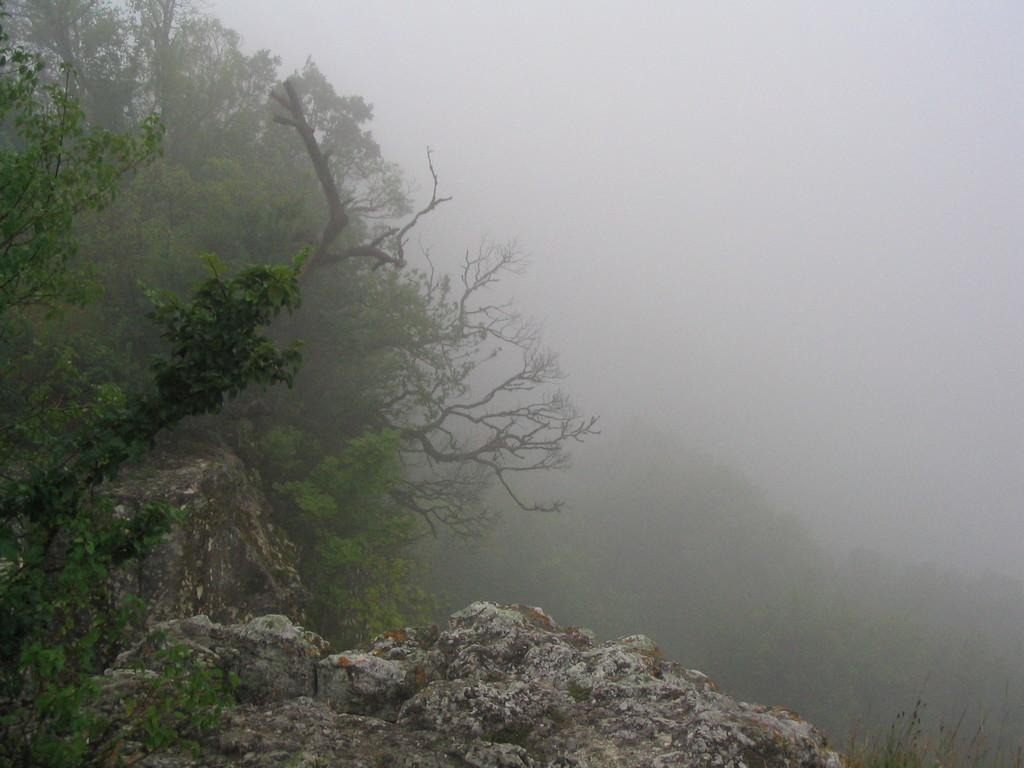What is located in the foreground of the image? There is a rock in the foreground of the image. What can be seen on the left side of the foreground? There are trees on the left side of the foreground. What is visible in the background of the image? There are trees and the sky in the background of the image. How would you describe the appearance of the sky? The sky appears to be foggy in the image. What type of silver butter pan can be seen in the image? There is no silver butter pan present in the image. 